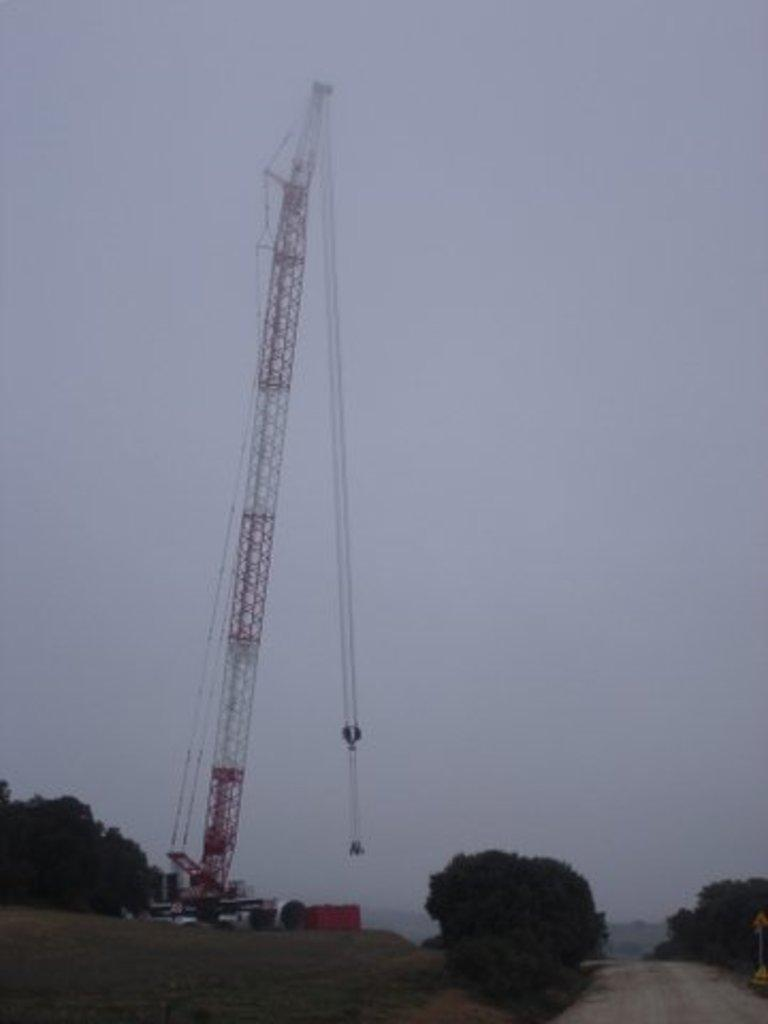What types of objects can be seen in the image? There are vehicles in the image. What else can be seen in the image besides vehicles? There are trees in the image. What can be seen in the background of the image? The sky is visible in the background of the image. Can you see any steam coming from the vehicles in the image? There is no mention of steam in the image, so it cannot be determined if any is present. 